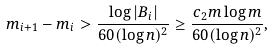<formula> <loc_0><loc_0><loc_500><loc_500>m _ { i + 1 } - m _ { i } > \frac { \log | B _ { i } | } { 6 0 ( \log n ) ^ { 2 } } \geq \frac { c _ { 2 } m \log m } { 6 0 ( \log n ) ^ { 2 } } ,</formula> 